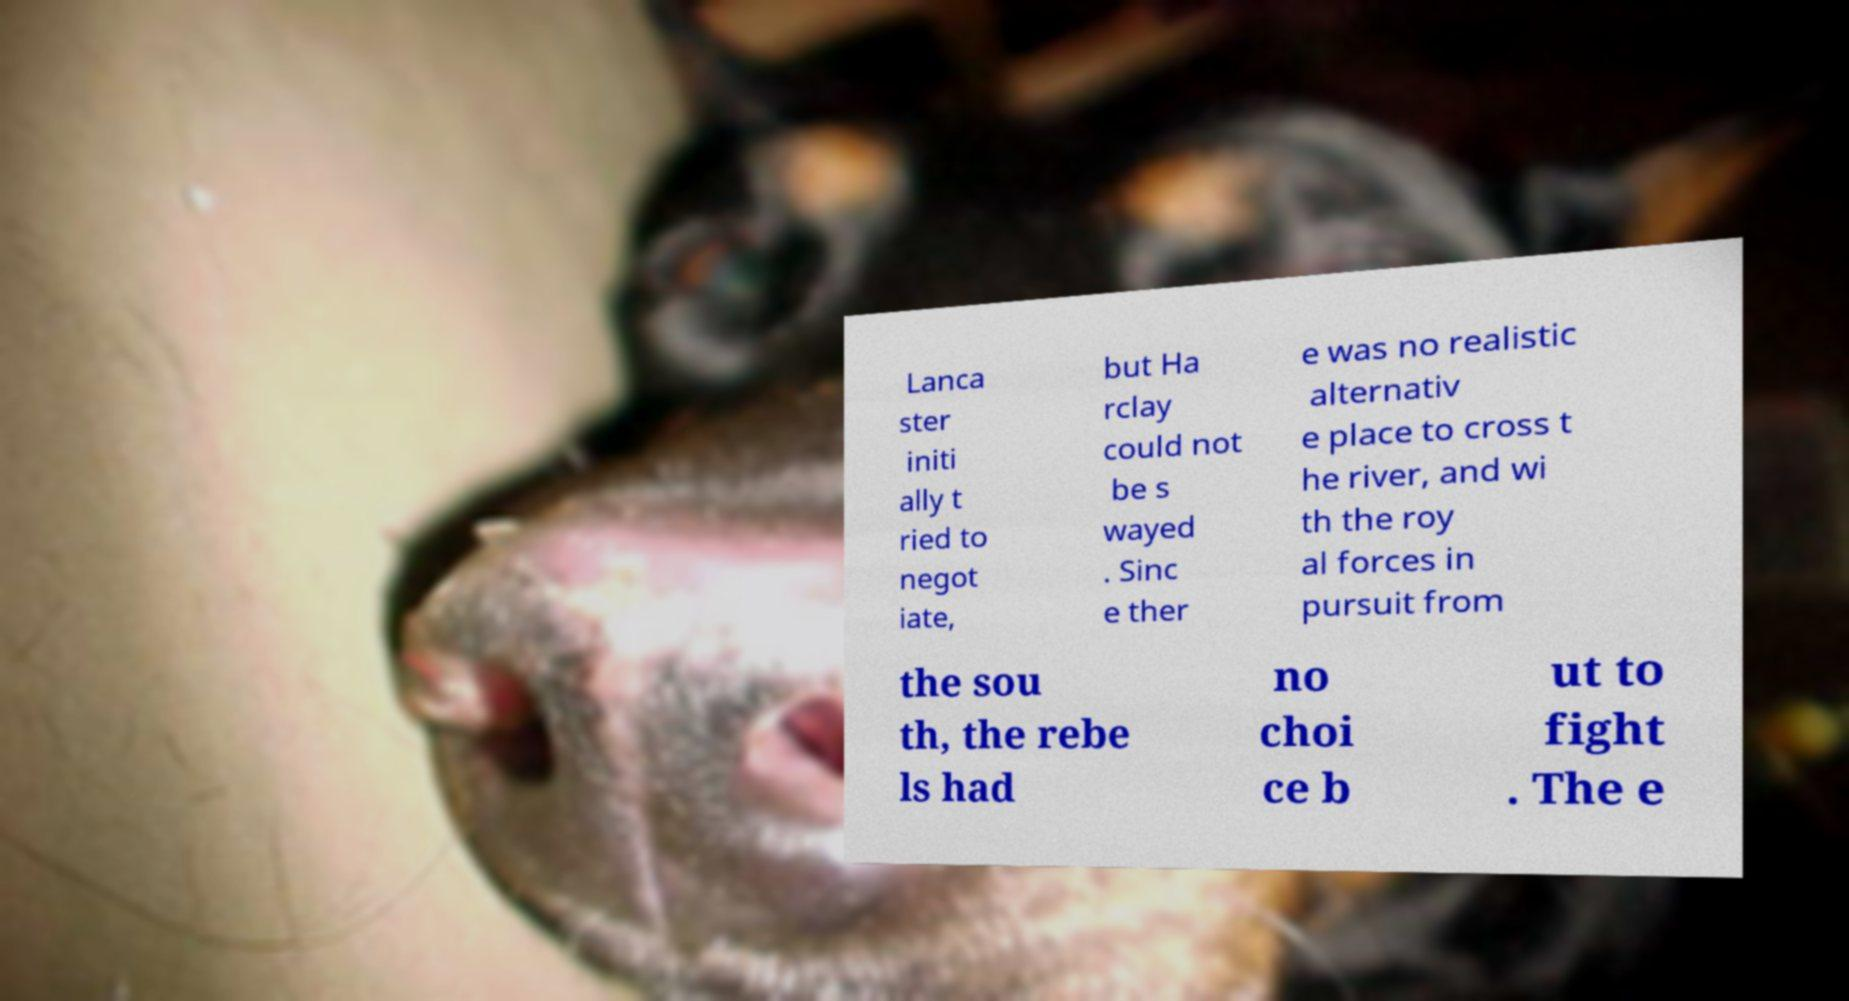Can you accurately transcribe the text from the provided image for me? Lanca ster initi ally t ried to negot iate, but Ha rclay could not be s wayed . Sinc e ther e was no realistic alternativ e place to cross t he river, and wi th the roy al forces in pursuit from the sou th, the rebe ls had no choi ce b ut to fight . The e 